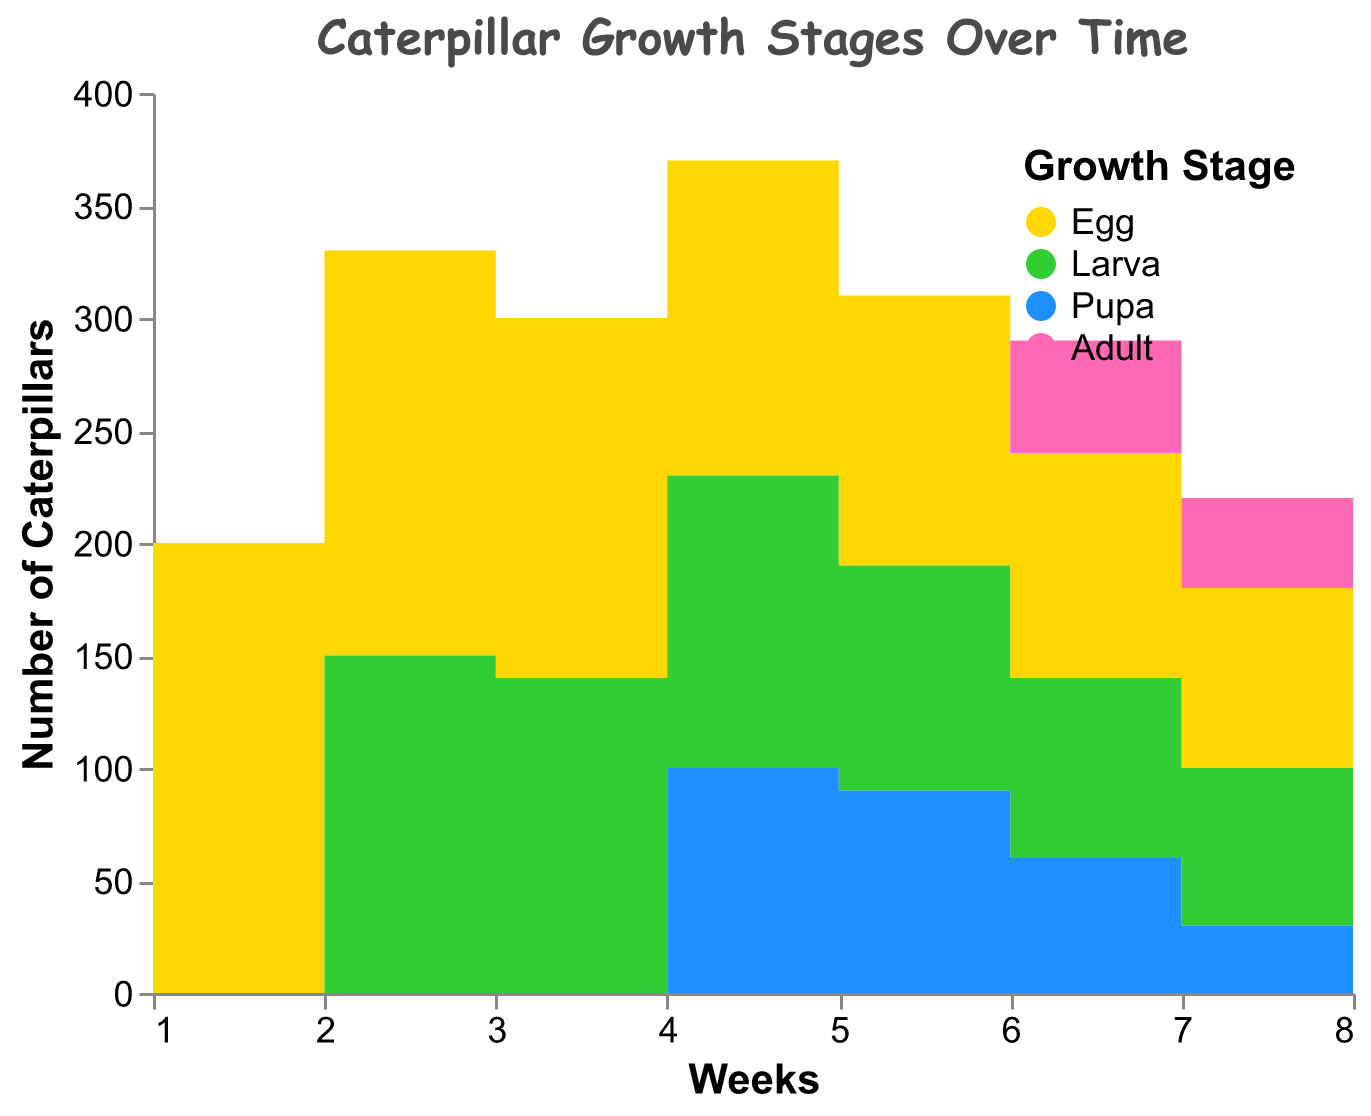What is the title of the figure? The title of the figure is located at the top and summarizes its content. It reads "Caterpillar Growth Stages Over Time".
Answer: Caterpillar Growth Stages Over Time What color represents the Larva stage? The legend at the top-right of the figure shows the colors corresponding to each growth stage. The Larva stage is represented by green.
Answer: Green How many caterpillars are in the Egg stage at Week 1? The y-axis represents the number of caterpillars, and Week 1 data shows 200 caterpillars in the Egg stage.
Answer: 200 At which week do caterpillars start appearing in the Adult stage? By looking at the data along the Weeks axis and counting the occurrences of caterpillars in the Adult stage, we see that they start appearing in Week 6.
Answer: Week 6 How many total caterpillars are there at Week 3 across all stages? Sum the counts across all stages at Week 3: Egg (160) + Larva (140) + Pupa (0) + Adult (0). So, 160 + 140 = 300 caterpillars.
Answer: 300 Which stage has the highest number of caterpillars in Week 8? By comparing the count values at Week 8 for each stage, the Adult stage has the highest number of caterpillars at 60.
Answer: Adult Compare the number of caterpillars in the Pupa stage between Week 6 and Week 7. Which week has more? In Week 6, there are 60 caterpillars in the Pupa stage. In Week 7, there are 30 caterpillars in the Pupa stage. So, Week 6 has more than Week 7.
Answer: Week 6 What pattern do you observe in the Egg stage count over the 8 weeks? The Egg stage count decreases steadily over the 8 weeks from 200 to 60.
Answer: Decreasing steadily How does the number of caterpillars in the Egg stage at Week 5 compare to the Larva stage at the same week? At Week 5, there are 120 caterpillars in the Egg stage and 100 in the Larva stage, so the Egg stage has a higher count.
Answer: Egg stage In which week do caterpillars in the Pupa stage first appear? According to the data, the caterpillars in the Pupa stage first appear in Week 4 with a count of 100.
Answer: Week 4 